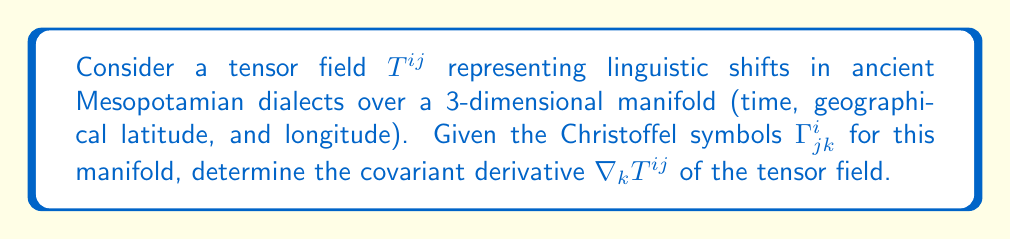Teach me how to tackle this problem. To find the covariant derivative of the tensor field $T^{ij}$, we follow these steps:

1. Recall the formula for the covariant derivative of a contravariant tensor of rank 2:

   $$\nabla_k T^{ij} = \partial_k T^{ij} + \Gamma^i_{lk} T^{lj} + \Gamma^j_{lk} T^{il}$$

2. Here, $\partial_k T^{ij}$ represents the partial derivative of $T^{ij}$ with respect to the $k$-th coordinate.

3. The Christoffel symbols $\Gamma^i_{jk}$ account for the curvature of the manifold, which in this context represents the non-uniform nature of linguistic changes across time and space in ancient Mesopotamia.

4. The terms $\Gamma^i_{lk} T^{lj}$ and $\Gamma^j_{lk} T^{il}$ involve summation over the repeated index $l$ (Einstein summation convention).

5. These additional terms adjust the partial derivative to account for how the basis vectors change across the manifold, ensuring that the covariant derivative properly captures the intrinsic linguistic shifts independent of the coordinate system.

6. The resulting $\nabla_k T^{ij}$ is a tensor of rank 3, representing how the linguistic shift tensor $T^{ij}$ changes along each dimension (time, latitude, longitude) while accounting for the underlying structure of the manifold.
Answer: $$\nabla_k T^{ij} = \partial_k T^{ij} + \Gamma^i_{lk} T^{lj} + \Gamma^j_{lk} T^{il}$$ 